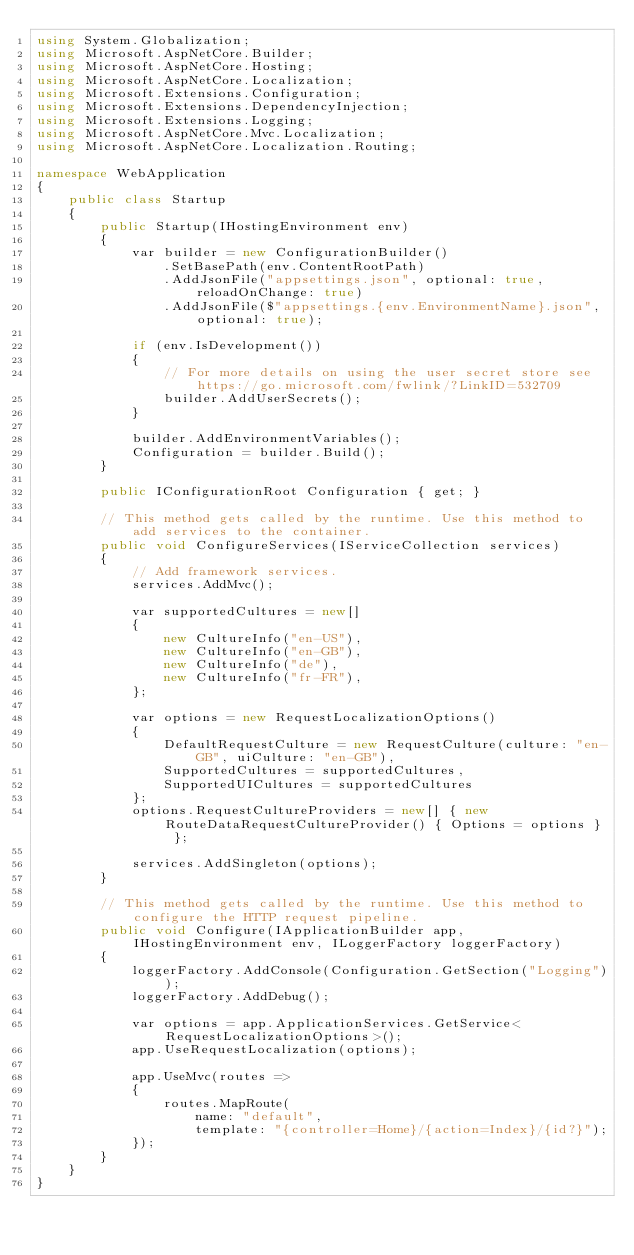Convert code to text. <code><loc_0><loc_0><loc_500><loc_500><_C#_>using System.Globalization;
using Microsoft.AspNetCore.Builder;
using Microsoft.AspNetCore.Hosting;
using Microsoft.AspNetCore.Localization;
using Microsoft.Extensions.Configuration;
using Microsoft.Extensions.DependencyInjection;
using Microsoft.Extensions.Logging;
using Microsoft.AspNetCore.Mvc.Localization;
using Microsoft.AspNetCore.Localization.Routing;

namespace WebApplication
{
    public class Startup
    {
        public Startup(IHostingEnvironment env)
        {
            var builder = new ConfigurationBuilder()
                .SetBasePath(env.ContentRootPath)
                .AddJsonFile("appsettings.json", optional: true, reloadOnChange: true)
                .AddJsonFile($"appsettings.{env.EnvironmentName}.json", optional: true);

            if (env.IsDevelopment())
            {
                // For more details on using the user secret store see https://go.microsoft.com/fwlink/?LinkID=532709
                builder.AddUserSecrets();
            }

            builder.AddEnvironmentVariables();
            Configuration = builder.Build();
        }

        public IConfigurationRoot Configuration { get; }

        // This method gets called by the runtime. Use this method to add services to the container.
        public void ConfigureServices(IServiceCollection services)
        {
            // Add framework services.
            services.AddMvc();

            var supportedCultures = new[]
            {
                new CultureInfo("en-US"),
                new CultureInfo("en-GB"),
                new CultureInfo("de"),
                new CultureInfo("fr-FR"),
            };

            var options = new RequestLocalizationOptions()
            {
                DefaultRequestCulture = new RequestCulture(culture: "en-GB", uiCulture: "en-GB"),
                SupportedCultures = supportedCultures,
                SupportedUICultures = supportedCultures
            };
            options.RequestCultureProviders = new[] { new RouteDataRequestCultureProvider() { Options = options } };

            services.AddSingleton(options);
        }

        // This method gets called by the runtime. Use this method to configure the HTTP request pipeline.
        public void Configure(IApplicationBuilder app, IHostingEnvironment env, ILoggerFactory loggerFactory)
        {
            loggerFactory.AddConsole(Configuration.GetSection("Logging"));
            loggerFactory.AddDebug();

            var options = app.ApplicationServices.GetService<RequestLocalizationOptions>();
            app.UseRequestLocalization(options);

            app.UseMvc(routes =>
            {
                routes.MapRoute(
                    name: "default",
                    template: "{controller=Home}/{action=Index}/{id?}");
            });
        }
    }
}
</code> 